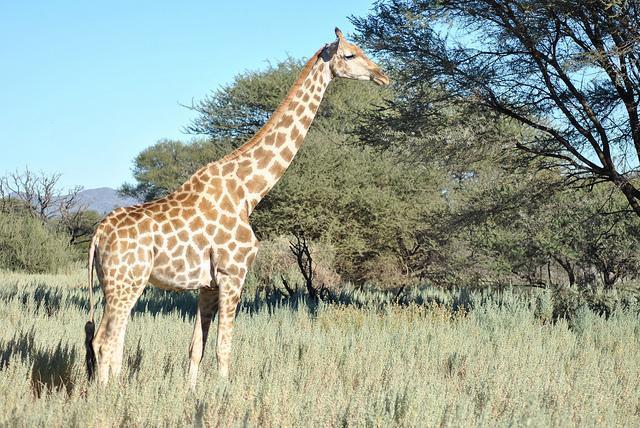How many giraffes are in the photo?
Give a very brief answer. 1. How many black cars are driving to the left of the bus?
Give a very brief answer. 0. 